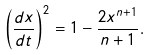Convert formula to latex. <formula><loc_0><loc_0><loc_500><loc_500>\left ( \frac { d x } { d t } \right ) ^ { 2 } = 1 - \frac { 2 x ^ { n + 1 } } { n + 1 } .</formula> 